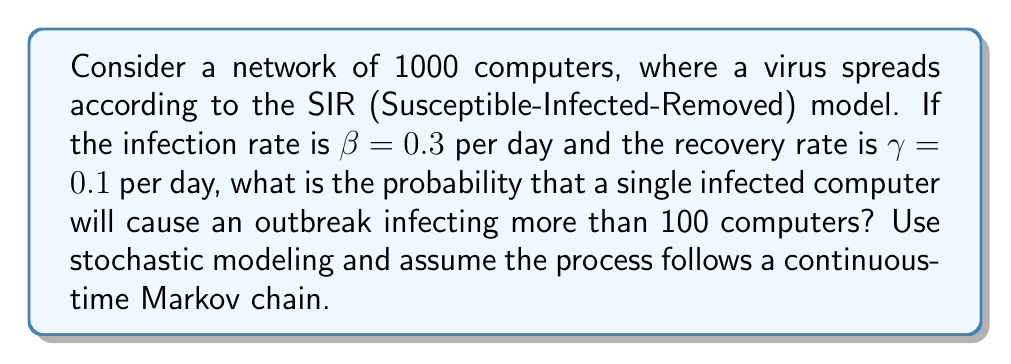Show me your answer to this math problem. To solve this problem, we'll use the stochastic SIR model and the concept of the basic reproduction number $R_0$.

Step 1: Calculate the basic reproduction number $R_0$.
$R_0 = \frac{\beta N}{\gamma}$, where N is the initial number of susceptible individuals.
$R_0 = \frac{0.3 \times 999}{0.1} = 2.997$

Step 2: Calculate the probability of extinction $p_e$.
For a continuous-time Markov chain SIR model, the probability of extinction is:
$p_e = \min(1, \frac{1}{R_0})$
$p_e = \min(1, \frac{1}{2.997}) = \frac{1}{2.997} \approx 0.3337$

Step 3: Calculate the probability of an outbreak (infecting more than 100 computers).
The probability of an outbreak is the complement of the probability of extinction:
$p_{outbreak} = 1 - p_e = 1 - 0.3337 = 0.6663$

Therefore, the probability that a single infected computer will cause an outbreak infecting more than 100 computers is approximately 0.6663 or 66.63%.
Answer: 0.6663 